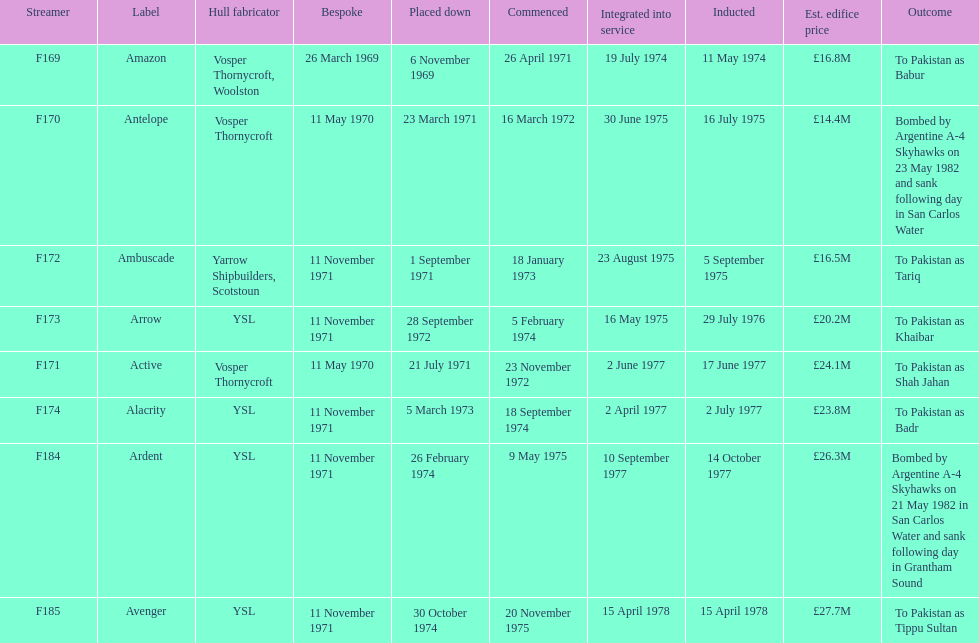What is the last name listed on this chart? Avenger. 